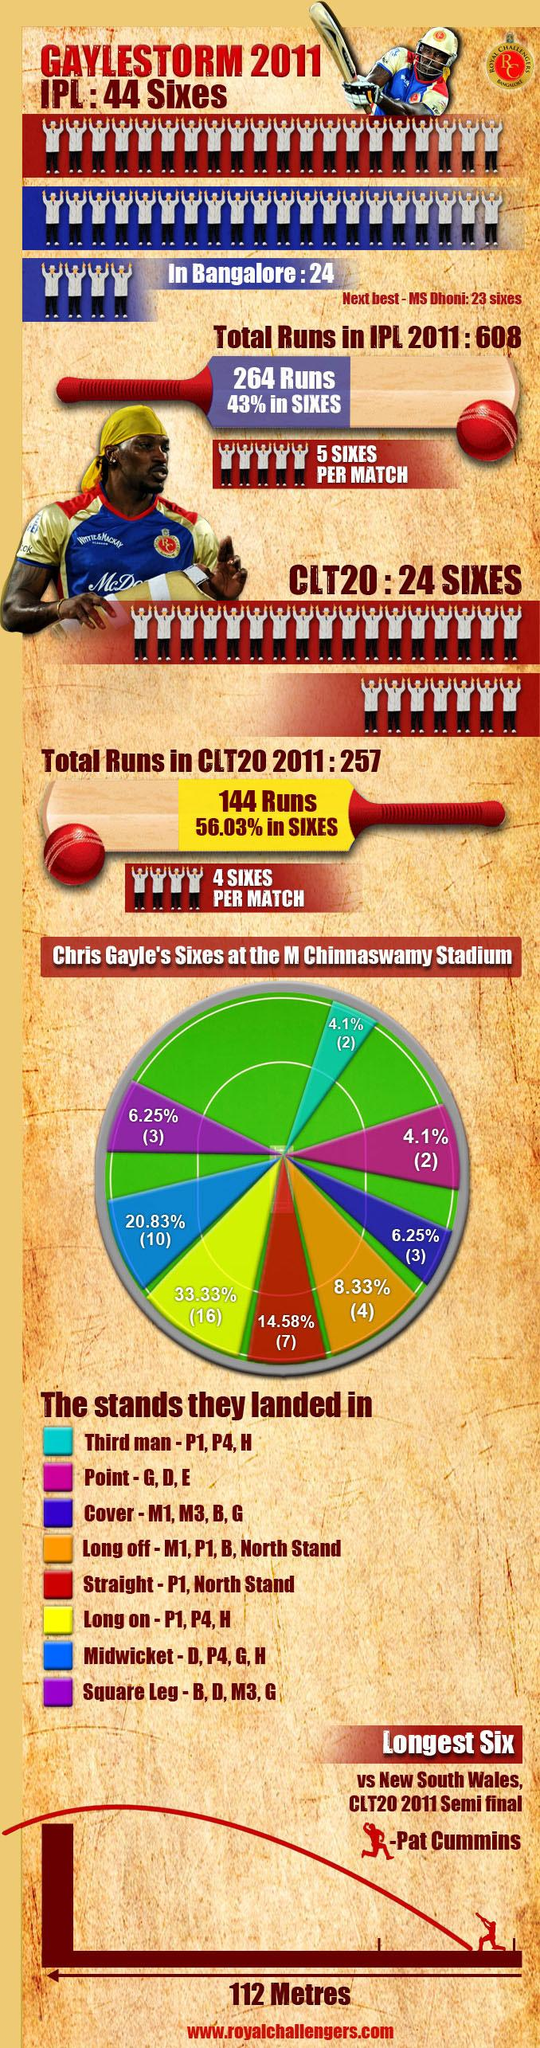Specify some key components in this picture. In square leg, there are three sixes. In the match against GayleStorm, the longest six was hit by the bowler Pat Cummins. Seven straight sixes have been hit. Mahendra Singh Dhoni holds the second-highest record of sixes in the Indian Premier League. There are ten sixes in midwicket. 